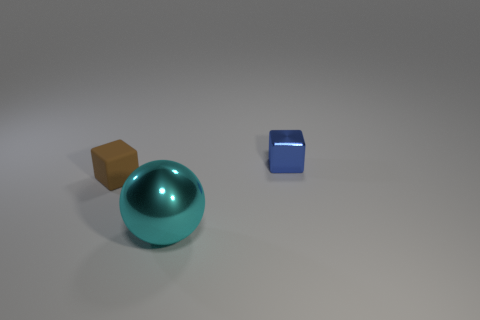Add 2 small things. How many objects exist? 5 Subtract all cubes. How many objects are left? 1 Add 2 tiny matte objects. How many tiny matte objects exist? 3 Subtract 0 blue cylinders. How many objects are left? 3 Subtract all small metal things. Subtract all rubber cubes. How many objects are left? 1 Add 2 large metal objects. How many large metal objects are left? 3 